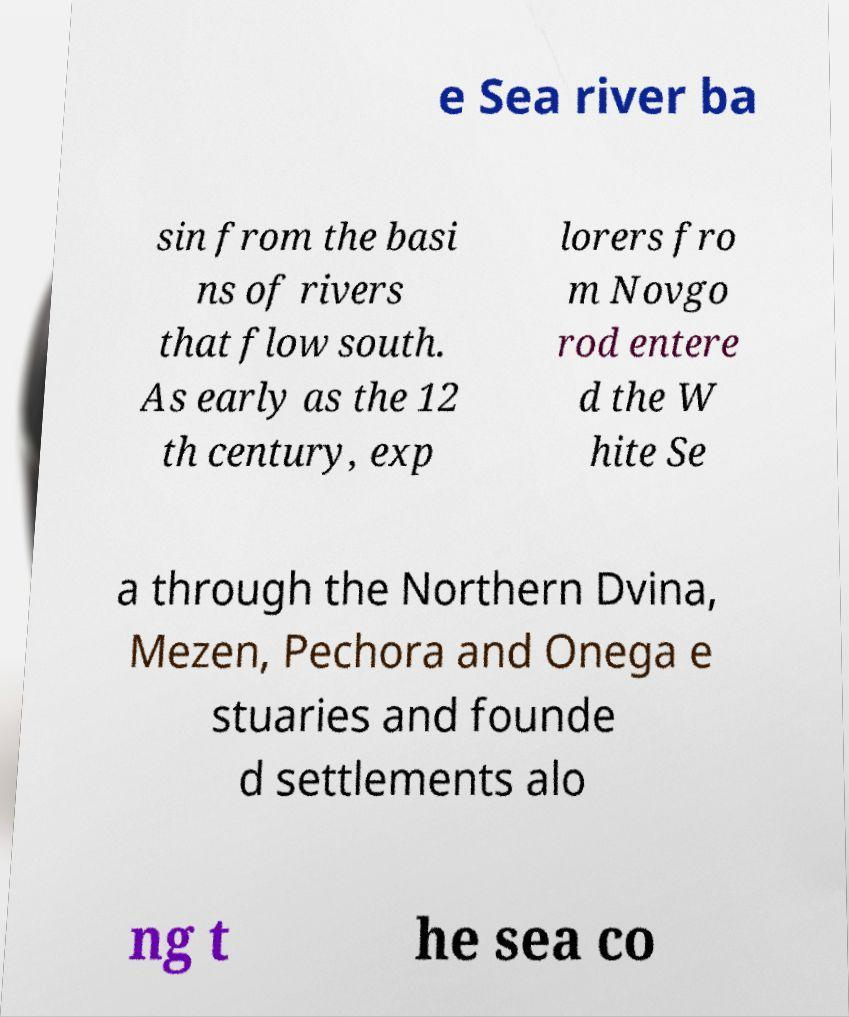Please identify and transcribe the text found in this image. e Sea river ba sin from the basi ns of rivers that flow south. As early as the 12 th century, exp lorers fro m Novgo rod entere d the W hite Se a through the Northern Dvina, Mezen, Pechora and Onega e stuaries and founde d settlements alo ng t he sea co 